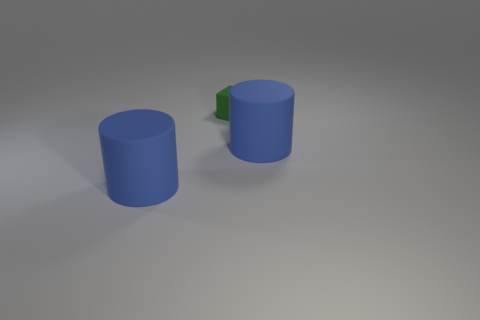Add 1 large matte things. How many objects exist? 4 Subtract all cylinders. How many objects are left? 1 Subtract all tiny yellow shiny cubes. Subtract all small green cubes. How many objects are left? 2 Add 2 green things. How many green things are left? 3 Add 1 gray shiny things. How many gray shiny things exist? 1 Subtract 0 brown blocks. How many objects are left? 3 